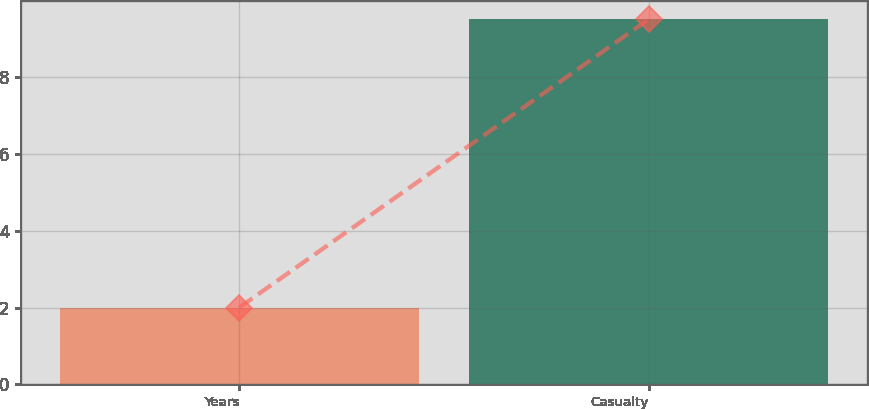Convert chart to OTSL. <chart><loc_0><loc_0><loc_500><loc_500><bar_chart><fcel>Years<fcel>Casualty<nl><fcel>2<fcel>9.5<nl></chart> 